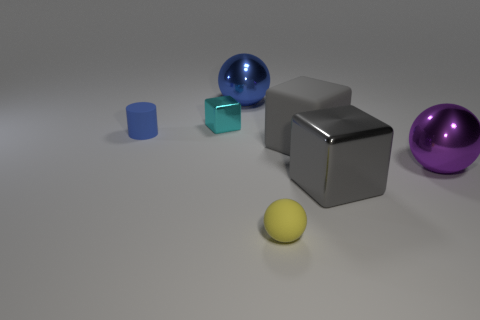There is a rubber object that is the same shape as the blue shiny thing; what is its color?
Give a very brief answer. Yellow. There is a shiny object that is to the right of the yellow ball and behind the large shiny cube; how big is it?
Give a very brief answer. Large. There is a large metal sphere that is right of the blue object that is on the right side of the small blue object; how many large gray metal objects are to the right of it?
Give a very brief answer. 0. What number of tiny objects are either blue rubber objects or brown cubes?
Offer a very short reply. 1. Are the sphere that is on the right side of the small matte sphere and the tiny yellow ball made of the same material?
Your answer should be compact. No. There is a big ball that is on the right side of the ball that is in front of the metal ball that is to the right of the small yellow matte object; what is it made of?
Offer a terse response. Metal. Is there anything else that is the same size as the purple metallic sphere?
Offer a very short reply. Yes. How many rubber objects are either blue spheres or tiny blue objects?
Provide a short and direct response. 1. Is there a gray ball?
Your answer should be compact. No. What is the color of the large sphere on the right side of the large shiny thing that is on the left side of the small yellow rubber thing?
Make the answer very short. Purple. 